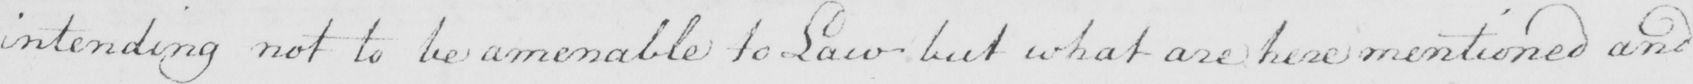Can you tell me what this handwritten text says? intending not to be amendable to Law but what are here mentioned and 